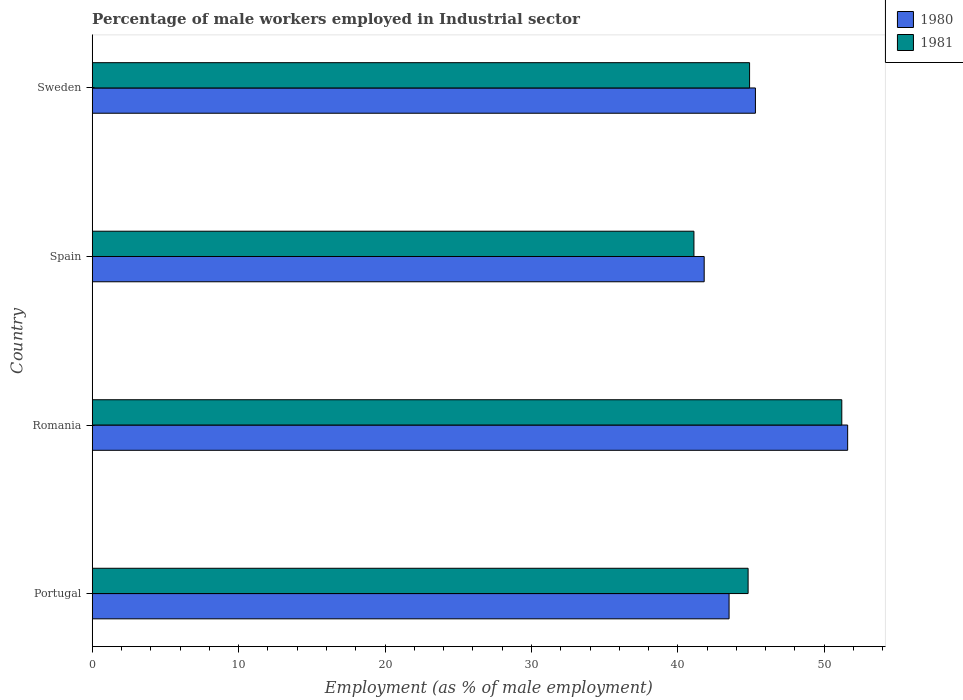Are the number of bars on each tick of the Y-axis equal?
Offer a terse response. Yes. How many bars are there on the 3rd tick from the bottom?
Your response must be concise. 2. In how many cases, is the number of bars for a given country not equal to the number of legend labels?
Give a very brief answer. 0. What is the percentage of male workers employed in Industrial sector in 1980 in Sweden?
Your answer should be compact. 45.3. Across all countries, what is the maximum percentage of male workers employed in Industrial sector in 1981?
Provide a succinct answer. 51.2. Across all countries, what is the minimum percentage of male workers employed in Industrial sector in 1981?
Provide a short and direct response. 41.1. In which country was the percentage of male workers employed in Industrial sector in 1981 maximum?
Offer a very short reply. Romania. In which country was the percentage of male workers employed in Industrial sector in 1981 minimum?
Provide a short and direct response. Spain. What is the total percentage of male workers employed in Industrial sector in 1981 in the graph?
Your answer should be very brief. 182. What is the difference between the percentage of male workers employed in Industrial sector in 1981 in Romania and that in Spain?
Provide a short and direct response. 10.1. What is the difference between the percentage of male workers employed in Industrial sector in 1981 in Portugal and the percentage of male workers employed in Industrial sector in 1980 in Romania?
Provide a short and direct response. -6.8. What is the average percentage of male workers employed in Industrial sector in 1981 per country?
Your answer should be compact. 45.5. What is the difference between the percentage of male workers employed in Industrial sector in 1980 and percentage of male workers employed in Industrial sector in 1981 in Portugal?
Ensure brevity in your answer.  -1.3. In how many countries, is the percentage of male workers employed in Industrial sector in 1980 greater than 48 %?
Your response must be concise. 1. What is the ratio of the percentage of male workers employed in Industrial sector in 1981 in Portugal to that in Sweden?
Your answer should be compact. 1. Is the percentage of male workers employed in Industrial sector in 1981 in Portugal less than that in Romania?
Keep it short and to the point. Yes. What is the difference between the highest and the second highest percentage of male workers employed in Industrial sector in 1980?
Your response must be concise. 6.3. What is the difference between the highest and the lowest percentage of male workers employed in Industrial sector in 1980?
Provide a short and direct response. 9.8. Is the sum of the percentage of male workers employed in Industrial sector in 1981 in Portugal and Sweden greater than the maximum percentage of male workers employed in Industrial sector in 1980 across all countries?
Your answer should be compact. Yes. What does the 2nd bar from the bottom in Spain represents?
Keep it short and to the point. 1981. Are all the bars in the graph horizontal?
Offer a very short reply. Yes. How many countries are there in the graph?
Offer a very short reply. 4. What is the difference between two consecutive major ticks on the X-axis?
Offer a terse response. 10. Are the values on the major ticks of X-axis written in scientific E-notation?
Your response must be concise. No. Does the graph contain grids?
Provide a succinct answer. No. How many legend labels are there?
Make the answer very short. 2. What is the title of the graph?
Ensure brevity in your answer.  Percentage of male workers employed in Industrial sector. Does "1973" appear as one of the legend labels in the graph?
Give a very brief answer. No. What is the label or title of the X-axis?
Give a very brief answer. Employment (as % of male employment). What is the Employment (as % of male employment) in 1980 in Portugal?
Offer a very short reply. 43.5. What is the Employment (as % of male employment) in 1981 in Portugal?
Keep it short and to the point. 44.8. What is the Employment (as % of male employment) of 1980 in Romania?
Offer a terse response. 51.6. What is the Employment (as % of male employment) of 1981 in Romania?
Provide a succinct answer. 51.2. What is the Employment (as % of male employment) of 1980 in Spain?
Your answer should be very brief. 41.8. What is the Employment (as % of male employment) of 1981 in Spain?
Your answer should be compact. 41.1. What is the Employment (as % of male employment) of 1980 in Sweden?
Your answer should be very brief. 45.3. What is the Employment (as % of male employment) of 1981 in Sweden?
Offer a terse response. 44.9. Across all countries, what is the maximum Employment (as % of male employment) in 1980?
Give a very brief answer. 51.6. Across all countries, what is the maximum Employment (as % of male employment) of 1981?
Offer a terse response. 51.2. Across all countries, what is the minimum Employment (as % of male employment) in 1980?
Offer a terse response. 41.8. Across all countries, what is the minimum Employment (as % of male employment) of 1981?
Provide a short and direct response. 41.1. What is the total Employment (as % of male employment) in 1980 in the graph?
Your response must be concise. 182.2. What is the total Employment (as % of male employment) of 1981 in the graph?
Give a very brief answer. 182. What is the difference between the Employment (as % of male employment) in 1981 in Portugal and that in Spain?
Give a very brief answer. 3.7. What is the difference between the Employment (as % of male employment) in 1981 in Portugal and that in Sweden?
Ensure brevity in your answer.  -0.1. What is the difference between the Employment (as % of male employment) in 1981 in Romania and that in Spain?
Your answer should be very brief. 10.1. What is the difference between the Employment (as % of male employment) of 1980 in Romania and that in Sweden?
Give a very brief answer. 6.3. What is the difference between the Employment (as % of male employment) of 1980 in Spain and that in Sweden?
Your response must be concise. -3.5. What is the difference between the Employment (as % of male employment) of 1981 in Spain and that in Sweden?
Your answer should be compact. -3.8. What is the difference between the Employment (as % of male employment) in 1980 in Portugal and the Employment (as % of male employment) in 1981 in Spain?
Give a very brief answer. 2.4. What is the difference between the Employment (as % of male employment) of 1980 in Portugal and the Employment (as % of male employment) of 1981 in Sweden?
Ensure brevity in your answer.  -1.4. What is the difference between the Employment (as % of male employment) in 1980 in Romania and the Employment (as % of male employment) in 1981 in Sweden?
Keep it short and to the point. 6.7. What is the average Employment (as % of male employment) in 1980 per country?
Provide a succinct answer. 45.55. What is the average Employment (as % of male employment) in 1981 per country?
Provide a short and direct response. 45.5. What is the difference between the Employment (as % of male employment) of 1980 and Employment (as % of male employment) of 1981 in Portugal?
Your answer should be compact. -1.3. What is the difference between the Employment (as % of male employment) of 1980 and Employment (as % of male employment) of 1981 in Spain?
Your response must be concise. 0.7. What is the difference between the Employment (as % of male employment) of 1980 and Employment (as % of male employment) of 1981 in Sweden?
Provide a short and direct response. 0.4. What is the ratio of the Employment (as % of male employment) in 1980 in Portugal to that in Romania?
Keep it short and to the point. 0.84. What is the ratio of the Employment (as % of male employment) in 1980 in Portugal to that in Spain?
Offer a terse response. 1.04. What is the ratio of the Employment (as % of male employment) of 1981 in Portugal to that in Spain?
Provide a short and direct response. 1.09. What is the ratio of the Employment (as % of male employment) in 1980 in Portugal to that in Sweden?
Ensure brevity in your answer.  0.96. What is the ratio of the Employment (as % of male employment) of 1981 in Portugal to that in Sweden?
Keep it short and to the point. 1. What is the ratio of the Employment (as % of male employment) of 1980 in Romania to that in Spain?
Offer a very short reply. 1.23. What is the ratio of the Employment (as % of male employment) of 1981 in Romania to that in Spain?
Provide a short and direct response. 1.25. What is the ratio of the Employment (as % of male employment) in 1980 in Romania to that in Sweden?
Make the answer very short. 1.14. What is the ratio of the Employment (as % of male employment) in 1981 in Romania to that in Sweden?
Offer a terse response. 1.14. What is the ratio of the Employment (as % of male employment) of 1980 in Spain to that in Sweden?
Provide a short and direct response. 0.92. What is the ratio of the Employment (as % of male employment) in 1981 in Spain to that in Sweden?
Ensure brevity in your answer.  0.92. What is the difference between the highest and the lowest Employment (as % of male employment) in 1980?
Provide a succinct answer. 9.8. What is the difference between the highest and the lowest Employment (as % of male employment) of 1981?
Your answer should be very brief. 10.1. 